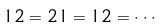<formula> <loc_0><loc_0><loc_500><loc_500>1 2 = 2 1 = 1 2 = \cdot \cdot \cdot</formula> 